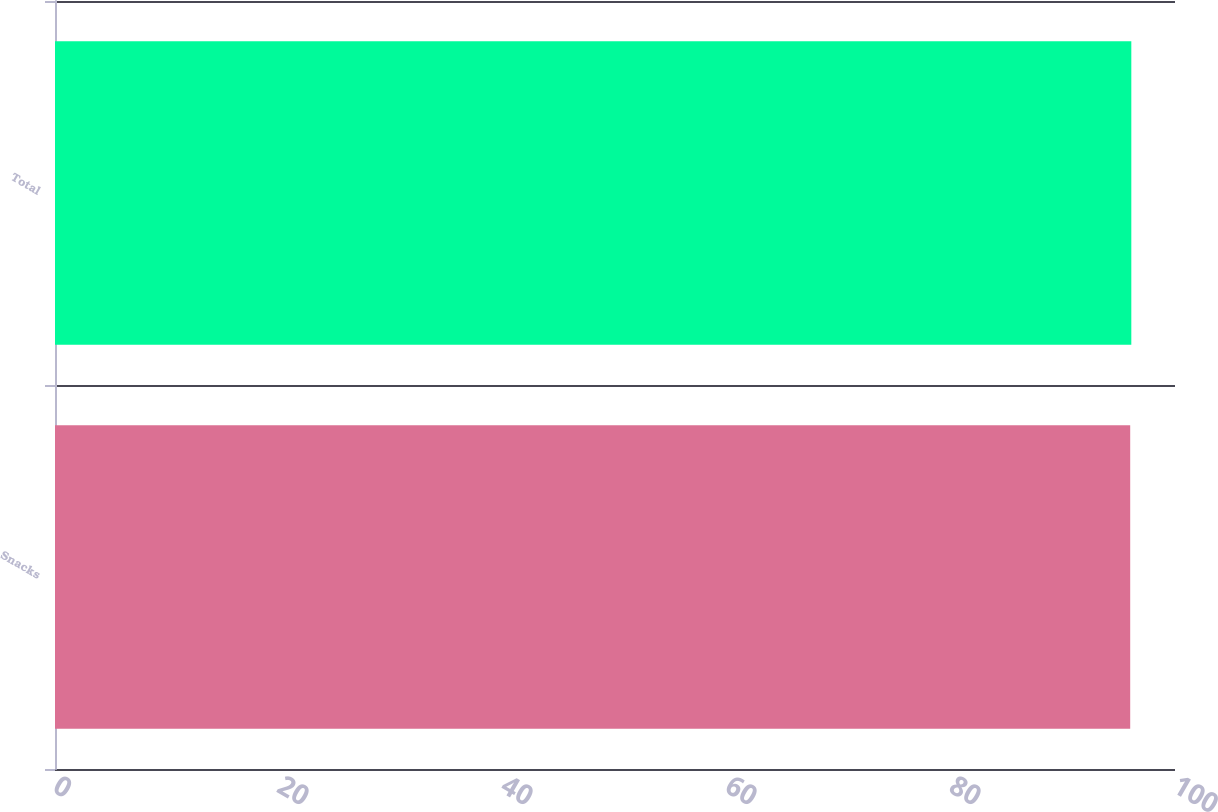Convert chart to OTSL. <chart><loc_0><loc_0><loc_500><loc_500><bar_chart><fcel>Snacks<fcel>Total<nl><fcel>96<fcel>96.1<nl></chart> 